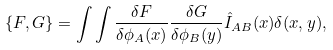<formula> <loc_0><loc_0><loc_500><loc_500>\{ F , G \} = \int \int \frac { \delta F } { \delta \phi _ { A } ( x ) } \frac { \delta G } { \delta \phi _ { B } ( y ) } \hat { I } _ { A B } ( x ) \delta ( x , y ) ,</formula> 